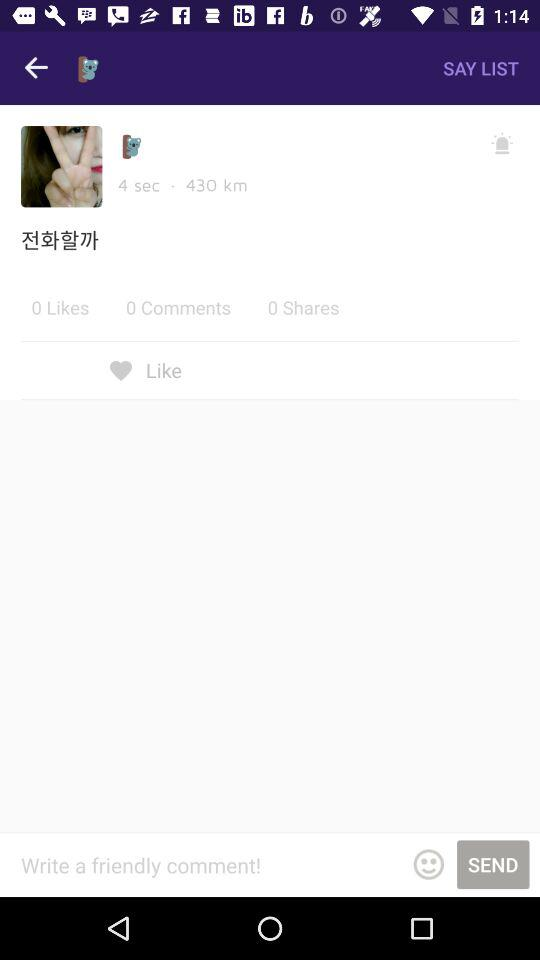What is the duration? The duration is 4 seconds. 